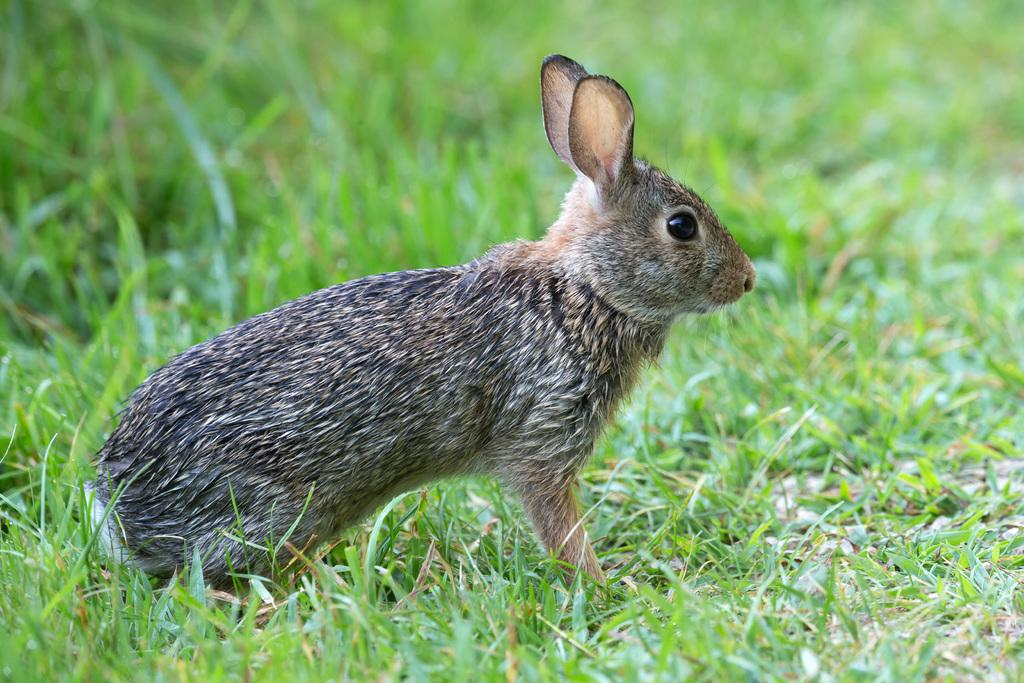What animal can be seen in the image? There is a rabbit in the image. Where is the rabbit located? The rabbit is sitting on the ground. What type of vegetation is present on the ground? There is grass on the ground. What type of boot can be seen on the rabbit's foot in the image? There is no boot present on the rabbit's foot in the image. What type of collar is the rabbit wearing in the image? There is no collar present on the rabbit in the image. 